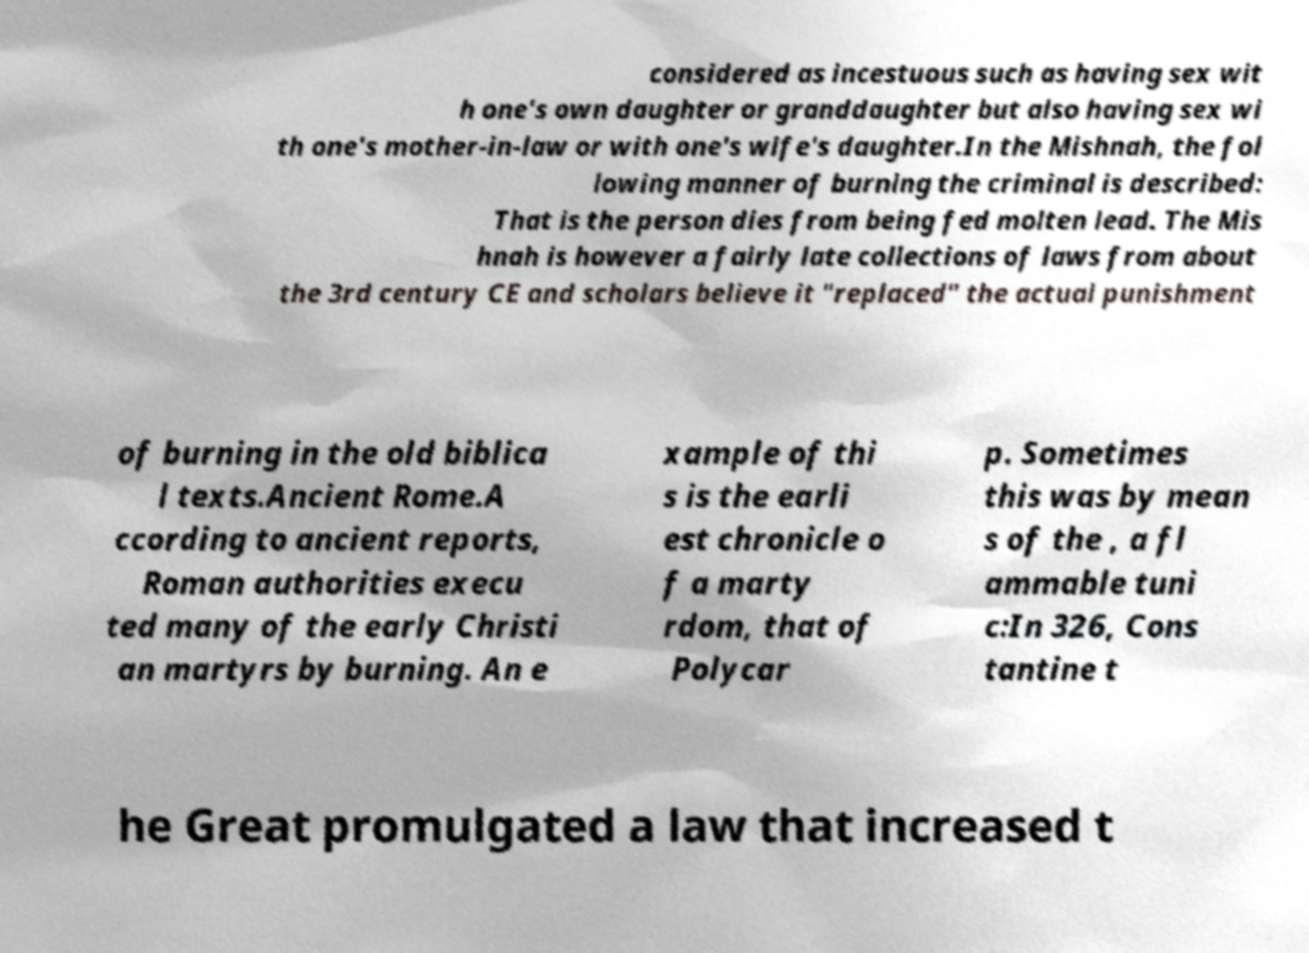I need the written content from this picture converted into text. Can you do that? considered as incestuous such as having sex wit h one's own daughter or granddaughter but also having sex wi th one's mother-in-law or with one's wife's daughter.In the Mishnah, the fol lowing manner of burning the criminal is described: That is the person dies from being fed molten lead. The Mis hnah is however a fairly late collections of laws from about the 3rd century CE and scholars believe it "replaced" the actual punishment of burning in the old biblica l texts.Ancient Rome.A ccording to ancient reports, Roman authorities execu ted many of the early Christi an martyrs by burning. An e xample of thi s is the earli est chronicle o f a marty rdom, that of Polycar p. Sometimes this was by mean s of the , a fl ammable tuni c:In 326, Cons tantine t he Great promulgated a law that increased t 